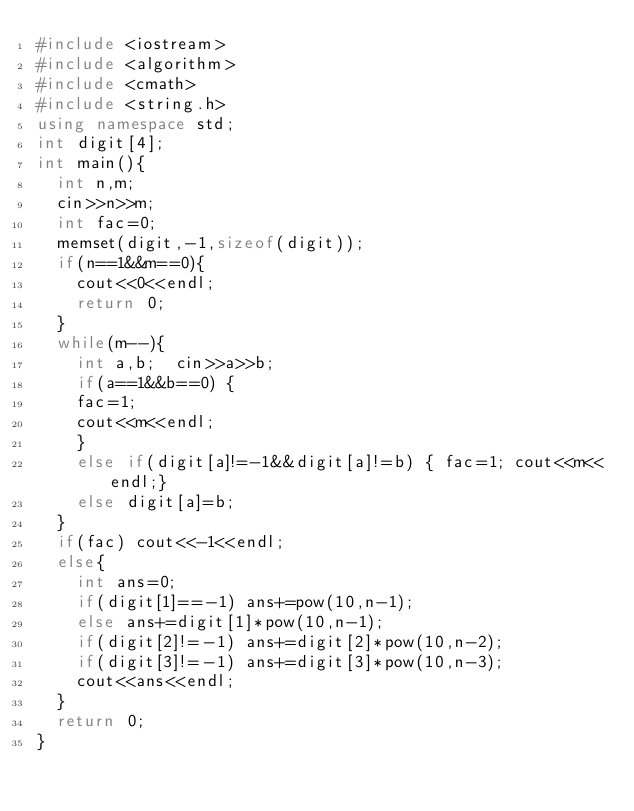Convert code to text. <code><loc_0><loc_0><loc_500><loc_500><_C++_>#include <iostream>
#include <algorithm>
#include <cmath>
#include <string.h>
using namespace std;
int digit[4];
int main(){
	int n,m;
	cin>>n>>m;
	int fac=0;
	memset(digit,-1,sizeof(digit));
	if(n==1&&m==0){
		cout<<0<<endl;
		return 0;
	}
	while(m--){
		int a,b;  cin>>a>>b;
		if(a==1&&b==0) {
		fac=1;
		cout<<m<<endl;
		}
		else if(digit[a]!=-1&&digit[a]!=b) { fac=1; cout<<m<<endl;}
		else digit[a]=b;
	}
	if(fac) cout<<-1<<endl;
	else{
		int ans=0;
		if(digit[1]==-1) ans+=pow(10,n-1);
		else ans+=digit[1]*pow(10,n-1);
		if(digit[2]!=-1) ans+=digit[2]*pow(10,n-2);
		if(digit[3]!=-1) ans+=digit[3]*pow(10,n-3);
		cout<<ans<<endl;
	}
	return 0;
}</code> 